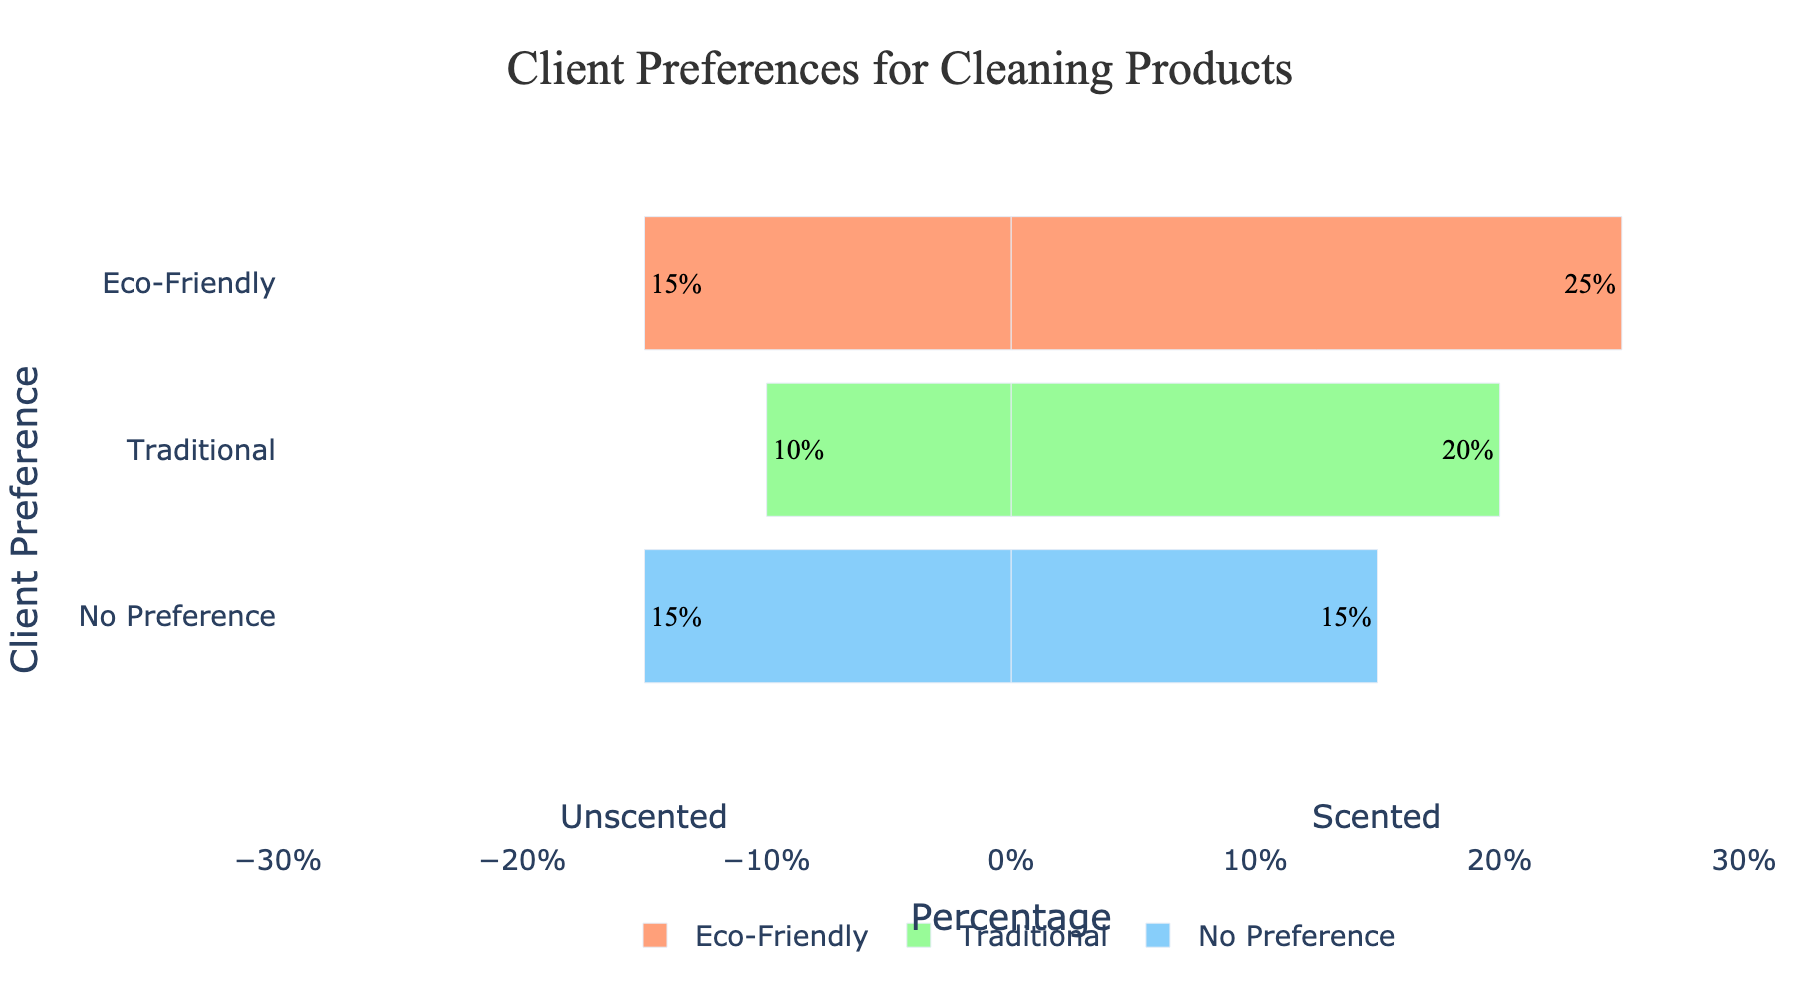What is the total percentage of clients who prefer Eco-Friendly products? Add the percentages of clients who prefer Eco-Friendly Scented and Eco-Friendly Unscented. So, it's 25% (Scented) + 15% (Unscented).
Answer: 40% Which cleaning product category do Traditional preference clients prefer the most, Scented or Unscented? Compare the percentages of Traditional Scented and Traditional Unscented. Traditional Scented has 20%, and Traditional Unscented has 10%.
Answer: Scented What is the combined percentage of clients with no preference for Scented and clients with no preference for Unscented? Sum the percentages of No Preference Scented and No Preference Unscented. So, it's 15% (Scented) + 15% (Unscented).
Answer: 30% Which preference has the lowest percentage for Unscented products? Compare the Unscented percentages for Eco-Friendly, Traditional, and No Preference. They are 15%, 10%, and 15%, respectively.
Answer: Traditional What is the difference in percentage between clients who prefer Eco-Friendly Scented and Traditional Scented products? Subtract the percentage of Traditional Scented from Eco-Friendly Scented. So, it's 25% - 20%.
Answer: 5% How much higher is the percentage of clients who prefer Traditional Scented products compared to Traditional Unscented products? Subtract the percentage of Traditional Unscented from Traditional Scented. So, it's 20% - 10%.
Answer: 10% Which preference category has an equal percentage of clients for Scented and Unscented products? Check for any preference where the percentage of Scented is equal to the percentage of Unscented. No Preference has 15% for both Scented and Unscented.
Answer: No Preference What is the overall percentage of clients who prefer Scented products? Sum the percentages of all Scented products across preferences: 25% (Eco-Friendly) + 20% (Traditional) + 15% (No Preference) = 60%.
Answer: 60% In which preference category are Unscented products the least popular? Compare the percentages of Unscented products across preferences. Traditional Unscented has the lowest percentage at 10%.
Answer: Traditional Which category (Scented or Unscented) is more popular among clients who prefer Eco-Friendly products? Compare the percentages of Eco-Friendly Scented and Eco-Friendly Unscented. Eco-Friendly Scented has 25%, while Eco-Friendly Unscented has 15%.
Answer: Scented 